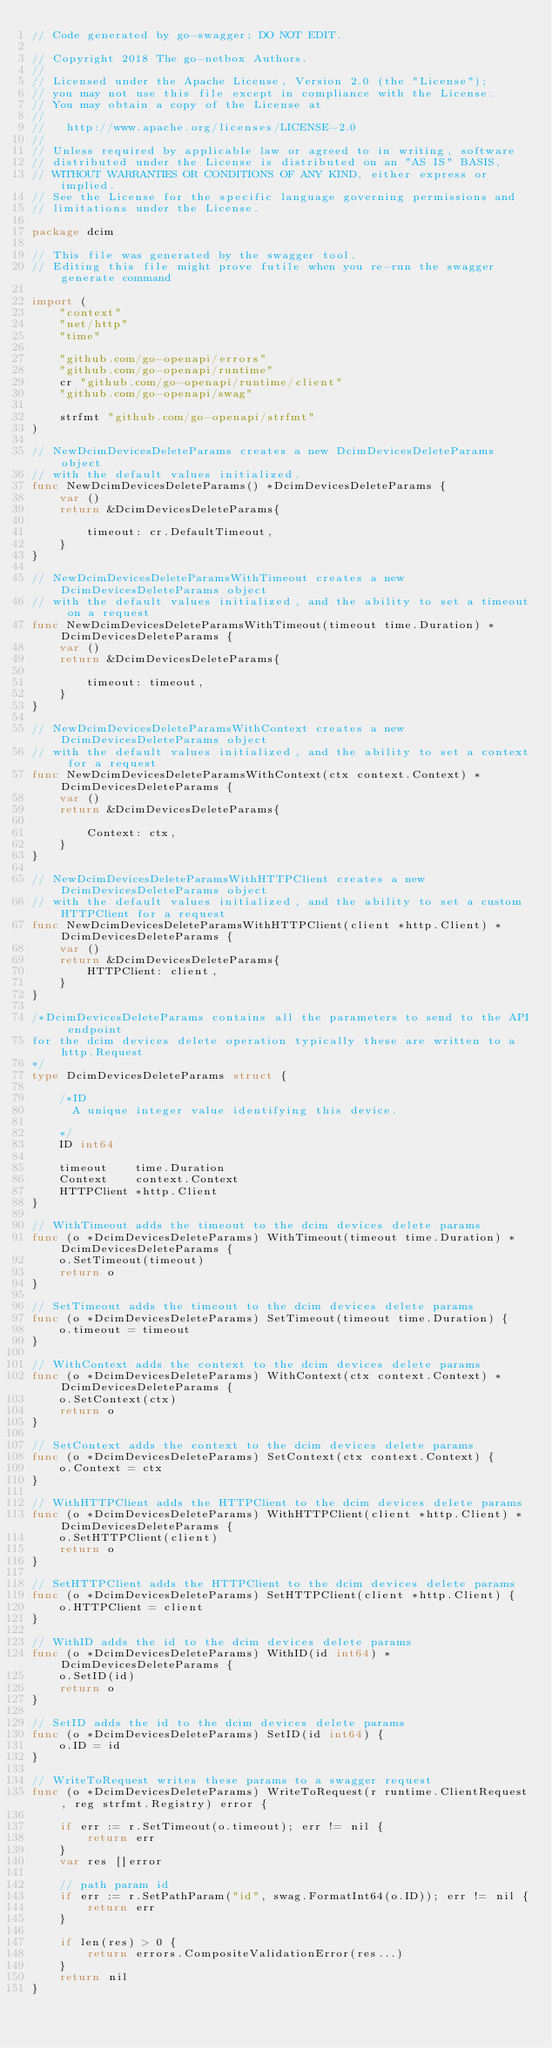Convert code to text. <code><loc_0><loc_0><loc_500><loc_500><_Go_>// Code generated by go-swagger; DO NOT EDIT.

// Copyright 2018 The go-netbox Authors.
//
// Licensed under the Apache License, Version 2.0 (the "License");
// you may not use this file except in compliance with the License.
// You may obtain a copy of the License at
//
//   http://www.apache.org/licenses/LICENSE-2.0
//
// Unless required by applicable law or agreed to in writing, software
// distributed under the License is distributed on an "AS IS" BASIS,
// WITHOUT WARRANTIES OR CONDITIONS OF ANY KIND, either express or implied.
// See the License for the specific language governing permissions and
// limitations under the License.

package dcim

// This file was generated by the swagger tool.
// Editing this file might prove futile when you re-run the swagger generate command

import (
	"context"
	"net/http"
	"time"

	"github.com/go-openapi/errors"
	"github.com/go-openapi/runtime"
	cr "github.com/go-openapi/runtime/client"
	"github.com/go-openapi/swag"

	strfmt "github.com/go-openapi/strfmt"
)

// NewDcimDevicesDeleteParams creates a new DcimDevicesDeleteParams object
// with the default values initialized.
func NewDcimDevicesDeleteParams() *DcimDevicesDeleteParams {
	var ()
	return &DcimDevicesDeleteParams{

		timeout: cr.DefaultTimeout,
	}
}

// NewDcimDevicesDeleteParamsWithTimeout creates a new DcimDevicesDeleteParams object
// with the default values initialized, and the ability to set a timeout on a request
func NewDcimDevicesDeleteParamsWithTimeout(timeout time.Duration) *DcimDevicesDeleteParams {
	var ()
	return &DcimDevicesDeleteParams{

		timeout: timeout,
	}
}

// NewDcimDevicesDeleteParamsWithContext creates a new DcimDevicesDeleteParams object
// with the default values initialized, and the ability to set a context for a request
func NewDcimDevicesDeleteParamsWithContext(ctx context.Context) *DcimDevicesDeleteParams {
	var ()
	return &DcimDevicesDeleteParams{

		Context: ctx,
	}
}

// NewDcimDevicesDeleteParamsWithHTTPClient creates a new DcimDevicesDeleteParams object
// with the default values initialized, and the ability to set a custom HTTPClient for a request
func NewDcimDevicesDeleteParamsWithHTTPClient(client *http.Client) *DcimDevicesDeleteParams {
	var ()
	return &DcimDevicesDeleteParams{
		HTTPClient: client,
	}
}

/*DcimDevicesDeleteParams contains all the parameters to send to the API endpoint
for the dcim devices delete operation typically these are written to a http.Request
*/
type DcimDevicesDeleteParams struct {

	/*ID
	  A unique integer value identifying this device.

	*/
	ID int64

	timeout    time.Duration
	Context    context.Context
	HTTPClient *http.Client
}

// WithTimeout adds the timeout to the dcim devices delete params
func (o *DcimDevicesDeleteParams) WithTimeout(timeout time.Duration) *DcimDevicesDeleteParams {
	o.SetTimeout(timeout)
	return o
}

// SetTimeout adds the timeout to the dcim devices delete params
func (o *DcimDevicesDeleteParams) SetTimeout(timeout time.Duration) {
	o.timeout = timeout
}

// WithContext adds the context to the dcim devices delete params
func (o *DcimDevicesDeleteParams) WithContext(ctx context.Context) *DcimDevicesDeleteParams {
	o.SetContext(ctx)
	return o
}

// SetContext adds the context to the dcim devices delete params
func (o *DcimDevicesDeleteParams) SetContext(ctx context.Context) {
	o.Context = ctx
}

// WithHTTPClient adds the HTTPClient to the dcim devices delete params
func (o *DcimDevicesDeleteParams) WithHTTPClient(client *http.Client) *DcimDevicesDeleteParams {
	o.SetHTTPClient(client)
	return o
}

// SetHTTPClient adds the HTTPClient to the dcim devices delete params
func (o *DcimDevicesDeleteParams) SetHTTPClient(client *http.Client) {
	o.HTTPClient = client
}

// WithID adds the id to the dcim devices delete params
func (o *DcimDevicesDeleteParams) WithID(id int64) *DcimDevicesDeleteParams {
	o.SetID(id)
	return o
}

// SetID adds the id to the dcim devices delete params
func (o *DcimDevicesDeleteParams) SetID(id int64) {
	o.ID = id
}

// WriteToRequest writes these params to a swagger request
func (o *DcimDevicesDeleteParams) WriteToRequest(r runtime.ClientRequest, reg strfmt.Registry) error {

	if err := r.SetTimeout(o.timeout); err != nil {
		return err
	}
	var res []error

	// path param id
	if err := r.SetPathParam("id", swag.FormatInt64(o.ID)); err != nil {
		return err
	}

	if len(res) > 0 {
		return errors.CompositeValidationError(res...)
	}
	return nil
}
</code> 